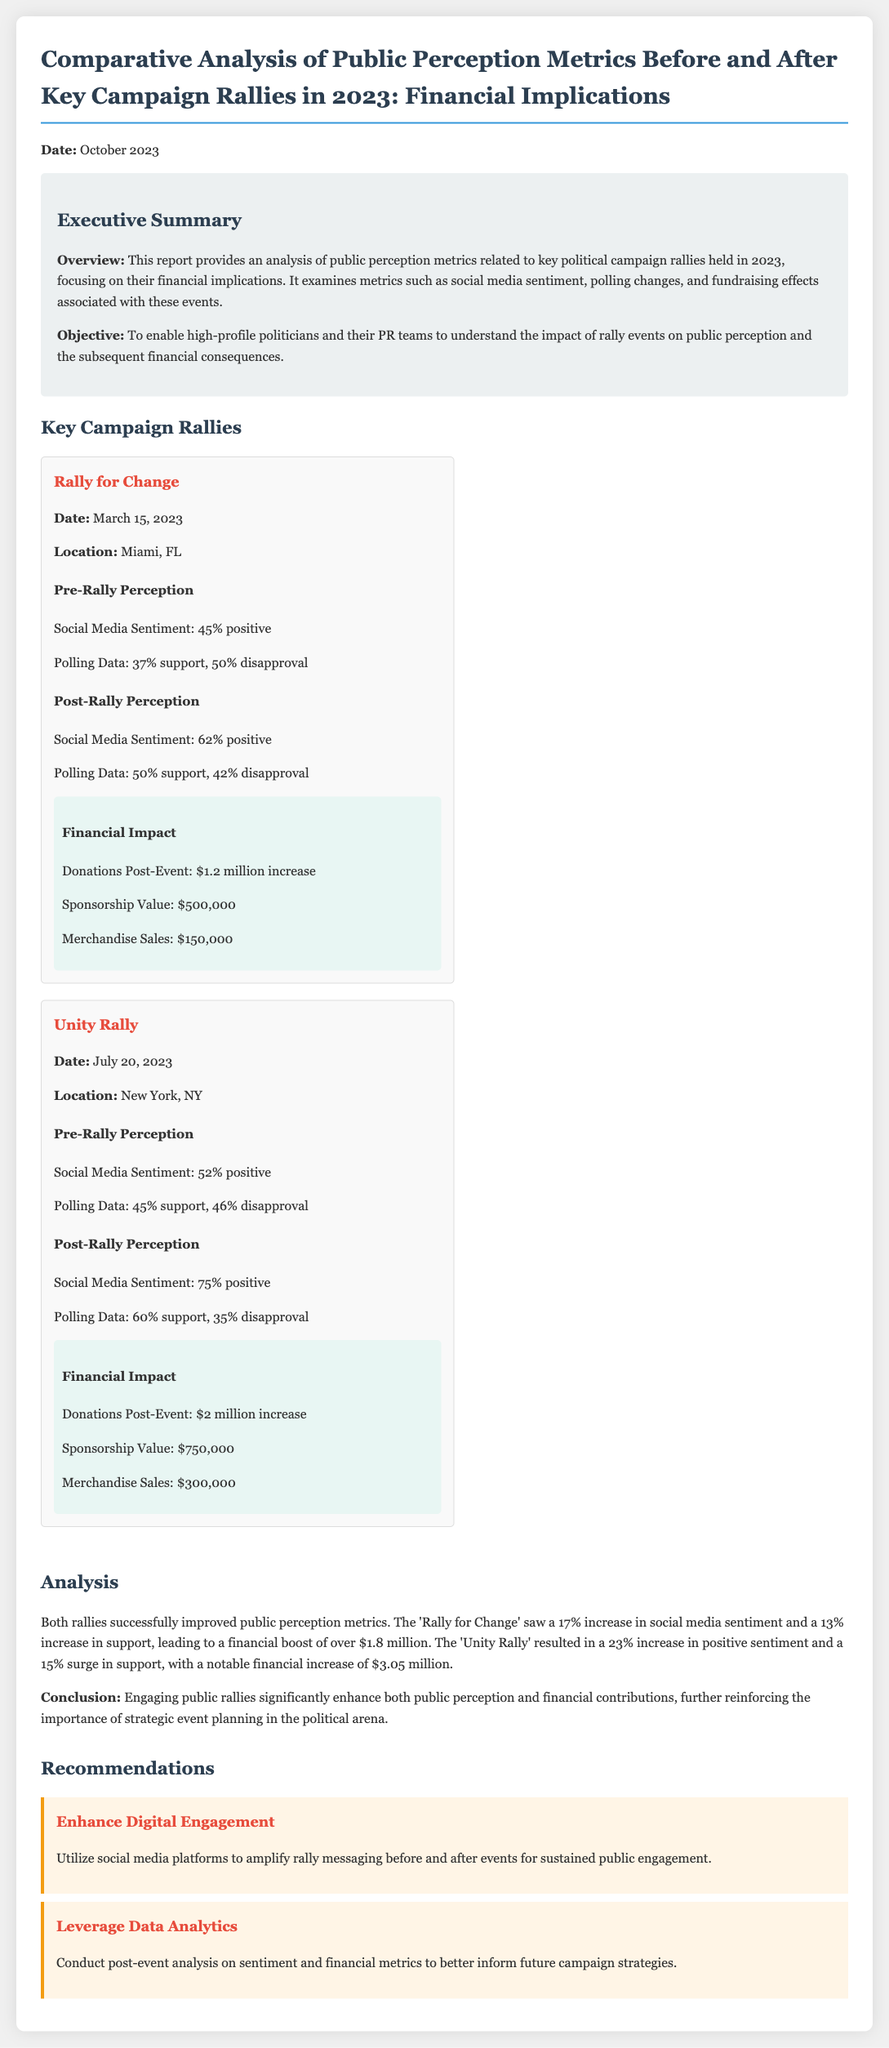What is the date of the report? The report is dated October 2023 as mentioned at the beginning.
Answer: October 2023 What was the social media sentiment before the 'Unity Rally'? The document states that the social media sentiment before the 'Unity Rally' was 52% positive.
Answer: 52% positive What is the increase in donations after the 'Rally for Change'? The financial impact states that there was a $1.2 million increase in donations post-event.
Answer: $1.2 million What location hosted the 'Rally for Change'? The document specifies that the 'Rally for Change' took place in Miami, FL.
Answer: Miami, FL By how much did polling support change for the 'Unity Rally'? The support increased from 45% to 60%, which is a 15% increase in polling support.
Answer: 15% What are two recommendations given in the report? The report offers recommendations to enhance digital engagement and leverage data analytics.
Answer: Enhance Digital Engagement, Leverage Data Analytics What was the total financial increase from the 'Unity Rally'? The document states the financial impact of the 'Unity Rally' resulted in a notable financial increase of $3.05 million.
Answer: $3.05 million What was the percentage increase of social media sentiment after the 'Rally for Change'? The social media sentiment increased from 45% to 62%, which indicates a 17% increase.
Answer: 17% How many key campaign rallies are analyzed in this report? The report analyzes two key campaign rallies: 'Rally for Change' and 'Unity Rally'.
Answer: Two 